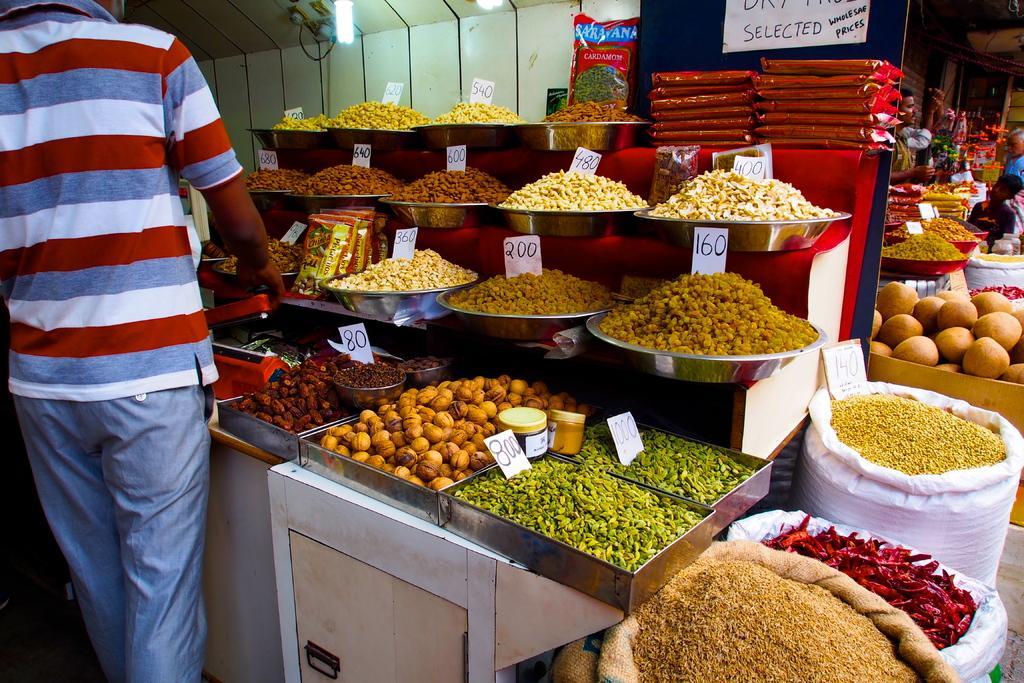Describe this image in one or two sentences. In this image there are some food items in bowls , trays and woven bags with price boards, and there are lights, packets , group of people, and in the background there are other items. 